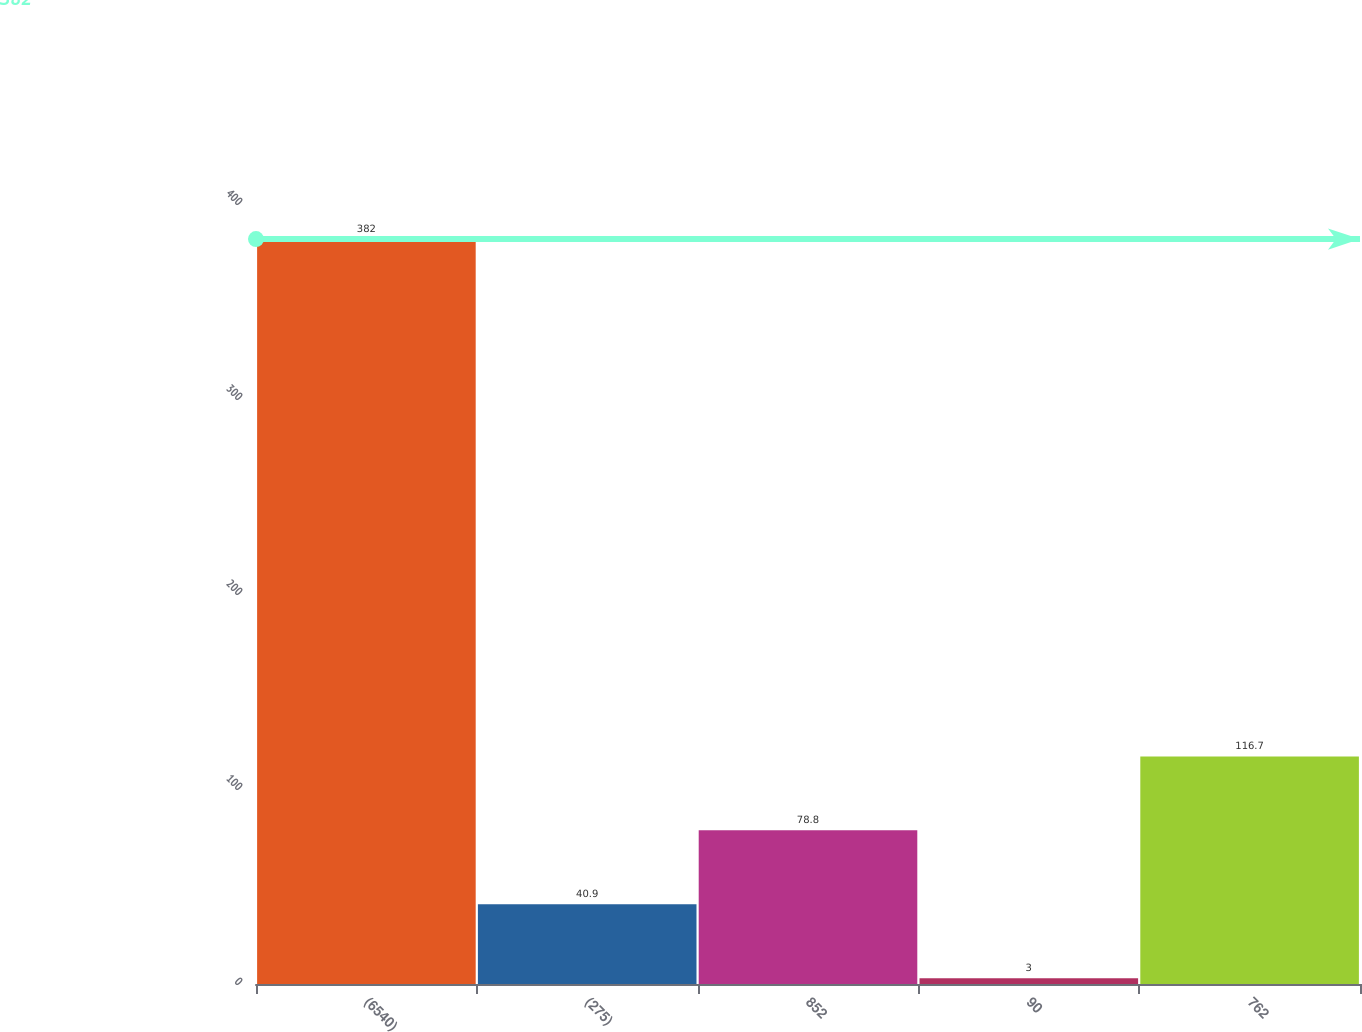Convert chart. <chart><loc_0><loc_0><loc_500><loc_500><bar_chart><fcel>(6540)<fcel>(275)<fcel>852<fcel>90<fcel>762<nl><fcel>382<fcel>40.9<fcel>78.8<fcel>3<fcel>116.7<nl></chart> 